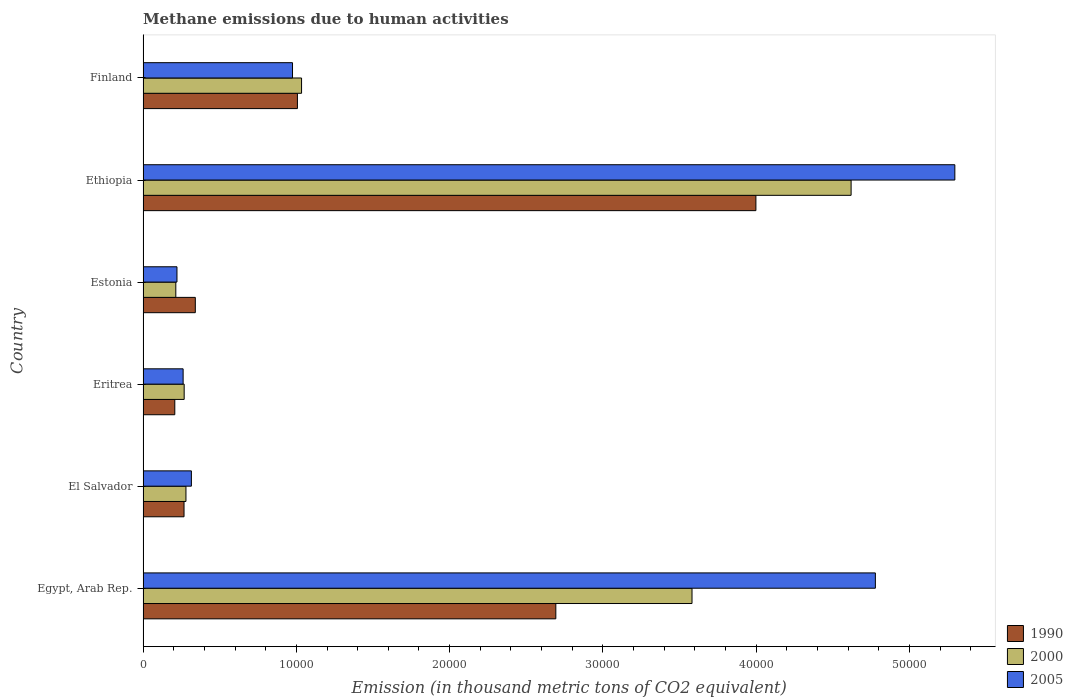What is the label of the 3rd group of bars from the top?
Provide a succinct answer. Estonia. What is the amount of methane emitted in 1990 in El Salvador?
Your response must be concise. 2672.9. Across all countries, what is the maximum amount of methane emitted in 2000?
Your response must be concise. 4.62e+04. Across all countries, what is the minimum amount of methane emitted in 2005?
Offer a very short reply. 2212.3. In which country was the amount of methane emitted in 2005 maximum?
Provide a short and direct response. Ethiopia. In which country was the amount of methane emitted in 1990 minimum?
Offer a terse response. Eritrea. What is the total amount of methane emitted in 2005 in the graph?
Provide a short and direct response. 1.18e+05. What is the difference between the amount of methane emitted in 2005 in El Salvador and that in Eritrea?
Provide a short and direct response. 539.2. What is the difference between the amount of methane emitted in 2005 in Eritrea and the amount of methane emitted in 1990 in Egypt, Arab Rep.?
Provide a short and direct response. -2.43e+04. What is the average amount of methane emitted in 2000 per country?
Keep it short and to the point. 1.67e+04. What is the difference between the amount of methane emitted in 2000 and amount of methane emitted in 1990 in Ethiopia?
Keep it short and to the point. 6210.5. In how many countries, is the amount of methane emitted in 1990 greater than 24000 thousand metric tons?
Offer a terse response. 2. What is the ratio of the amount of methane emitted in 2000 in Egypt, Arab Rep. to that in El Salvador?
Keep it short and to the point. 12.8. Is the amount of methane emitted in 1990 in Eritrea less than that in Ethiopia?
Offer a terse response. Yes. What is the difference between the highest and the second highest amount of methane emitted in 2005?
Give a very brief answer. 5184.5. What is the difference between the highest and the lowest amount of methane emitted in 2000?
Offer a terse response. 4.41e+04. In how many countries, is the amount of methane emitted in 2000 greater than the average amount of methane emitted in 2000 taken over all countries?
Give a very brief answer. 2. Is the sum of the amount of methane emitted in 1990 in El Salvador and Estonia greater than the maximum amount of methane emitted in 2005 across all countries?
Your answer should be very brief. No. What does the 1st bar from the top in El Salvador represents?
Ensure brevity in your answer.  2005. Are all the bars in the graph horizontal?
Give a very brief answer. Yes. Does the graph contain any zero values?
Provide a succinct answer. No. Does the graph contain grids?
Provide a succinct answer. No. Where does the legend appear in the graph?
Keep it short and to the point. Bottom right. What is the title of the graph?
Give a very brief answer. Methane emissions due to human activities. What is the label or title of the X-axis?
Offer a terse response. Emission (in thousand metric tons of CO2 equivalent). What is the Emission (in thousand metric tons of CO2 equivalent) of 1990 in Egypt, Arab Rep.?
Your response must be concise. 2.69e+04. What is the Emission (in thousand metric tons of CO2 equivalent) of 2000 in Egypt, Arab Rep.?
Make the answer very short. 3.58e+04. What is the Emission (in thousand metric tons of CO2 equivalent) of 2005 in Egypt, Arab Rep.?
Make the answer very short. 4.78e+04. What is the Emission (in thousand metric tons of CO2 equivalent) in 1990 in El Salvador?
Ensure brevity in your answer.  2672.9. What is the Emission (in thousand metric tons of CO2 equivalent) of 2000 in El Salvador?
Your response must be concise. 2798.1. What is the Emission (in thousand metric tons of CO2 equivalent) of 2005 in El Salvador?
Offer a very short reply. 3152.8. What is the Emission (in thousand metric tons of CO2 equivalent) of 1990 in Eritrea?
Provide a succinct answer. 2070.6. What is the Emission (in thousand metric tons of CO2 equivalent) in 2000 in Eritrea?
Keep it short and to the point. 2682.3. What is the Emission (in thousand metric tons of CO2 equivalent) in 2005 in Eritrea?
Give a very brief answer. 2613.6. What is the Emission (in thousand metric tons of CO2 equivalent) in 1990 in Estonia?
Your answer should be very brief. 3408.3. What is the Emission (in thousand metric tons of CO2 equivalent) of 2000 in Estonia?
Your answer should be compact. 2136.3. What is the Emission (in thousand metric tons of CO2 equivalent) of 2005 in Estonia?
Keep it short and to the point. 2212.3. What is the Emission (in thousand metric tons of CO2 equivalent) of 1990 in Ethiopia?
Keep it short and to the point. 4.00e+04. What is the Emission (in thousand metric tons of CO2 equivalent) in 2000 in Ethiopia?
Your answer should be compact. 4.62e+04. What is the Emission (in thousand metric tons of CO2 equivalent) in 2005 in Ethiopia?
Your answer should be compact. 5.30e+04. What is the Emission (in thousand metric tons of CO2 equivalent) in 1990 in Finland?
Your answer should be very brief. 1.01e+04. What is the Emission (in thousand metric tons of CO2 equivalent) in 2000 in Finland?
Give a very brief answer. 1.03e+04. What is the Emission (in thousand metric tons of CO2 equivalent) in 2005 in Finland?
Offer a very short reply. 9750. Across all countries, what is the maximum Emission (in thousand metric tons of CO2 equivalent) of 1990?
Offer a very short reply. 4.00e+04. Across all countries, what is the maximum Emission (in thousand metric tons of CO2 equivalent) of 2000?
Keep it short and to the point. 4.62e+04. Across all countries, what is the maximum Emission (in thousand metric tons of CO2 equivalent) of 2005?
Provide a short and direct response. 5.30e+04. Across all countries, what is the minimum Emission (in thousand metric tons of CO2 equivalent) of 1990?
Keep it short and to the point. 2070.6. Across all countries, what is the minimum Emission (in thousand metric tons of CO2 equivalent) of 2000?
Your response must be concise. 2136.3. Across all countries, what is the minimum Emission (in thousand metric tons of CO2 equivalent) in 2005?
Ensure brevity in your answer.  2212.3. What is the total Emission (in thousand metric tons of CO2 equivalent) of 1990 in the graph?
Offer a very short reply. 8.51e+04. What is the total Emission (in thousand metric tons of CO2 equivalent) of 2000 in the graph?
Your answer should be compact. 1.00e+05. What is the total Emission (in thousand metric tons of CO2 equivalent) of 2005 in the graph?
Make the answer very short. 1.18e+05. What is the difference between the Emission (in thousand metric tons of CO2 equivalent) of 1990 in Egypt, Arab Rep. and that in El Salvador?
Your response must be concise. 2.43e+04. What is the difference between the Emission (in thousand metric tons of CO2 equivalent) of 2000 in Egypt, Arab Rep. and that in El Salvador?
Your answer should be very brief. 3.30e+04. What is the difference between the Emission (in thousand metric tons of CO2 equivalent) in 2005 in Egypt, Arab Rep. and that in El Salvador?
Offer a very short reply. 4.46e+04. What is the difference between the Emission (in thousand metric tons of CO2 equivalent) of 1990 in Egypt, Arab Rep. and that in Eritrea?
Keep it short and to the point. 2.49e+04. What is the difference between the Emission (in thousand metric tons of CO2 equivalent) of 2000 in Egypt, Arab Rep. and that in Eritrea?
Keep it short and to the point. 3.31e+04. What is the difference between the Emission (in thousand metric tons of CO2 equivalent) in 2005 in Egypt, Arab Rep. and that in Eritrea?
Offer a very short reply. 4.52e+04. What is the difference between the Emission (in thousand metric tons of CO2 equivalent) of 1990 in Egypt, Arab Rep. and that in Estonia?
Make the answer very short. 2.35e+04. What is the difference between the Emission (in thousand metric tons of CO2 equivalent) in 2000 in Egypt, Arab Rep. and that in Estonia?
Keep it short and to the point. 3.37e+04. What is the difference between the Emission (in thousand metric tons of CO2 equivalent) in 2005 in Egypt, Arab Rep. and that in Estonia?
Your response must be concise. 4.56e+04. What is the difference between the Emission (in thousand metric tons of CO2 equivalent) in 1990 in Egypt, Arab Rep. and that in Ethiopia?
Your response must be concise. -1.31e+04. What is the difference between the Emission (in thousand metric tons of CO2 equivalent) of 2000 in Egypt, Arab Rep. and that in Ethiopia?
Make the answer very short. -1.04e+04. What is the difference between the Emission (in thousand metric tons of CO2 equivalent) in 2005 in Egypt, Arab Rep. and that in Ethiopia?
Make the answer very short. -5184.5. What is the difference between the Emission (in thousand metric tons of CO2 equivalent) of 1990 in Egypt, Arab Rep. and that in Finland?
Keep it short and to the point. 1.69e+04. What is the difference between the Emission (in thousand metric tons of CO2 equivalent) of 2000 in Egypt, Arab Rep. and that in Finland?
Offer a very short reply. 2.55e+04. What is the difference between the Emission (in thousand metric tons of CO2 equivalent) of 2005 in Egypt, Arab Rep. and that in Finland?
Keep it short and to the point. 3.80e+04. What is the difference between the Emission (in thousand metric tons of CO2 equivalent) in 1990 in El Salvador and that in Eritrea?
Offer a terse response. 602.3. What is the difference between the Emission (in thousand metric tons of CO2 equivalent) in 2000 in El Salvador and that in Eritrea?
Your answer should be compact. 115.8. What is the difference between the Emission (in thousand metric tons of CO2 equivalent) in 2005 in El Salvador and that in Eritrea?
Give a very brief answer. 539.2. What is the difference between the Emission (in thousand metric tons of CO2 equivalent) in 1990 in El Salvador and that in Estonia?
Offer a terse response. -735.4. What is the difference between the Emission (in thousand metric tons of CO2 equivalent) in 2000 in El Salvador and that in Estonia?
Offer a terse response. 661.8. What is the difference between the Emission (in thousand metric tons of CO2 equivalent) of 2005 in El Salvador and that in Estonia?
Your answer should be very brief. 940.5. What is the difference between the Emission (in thousand metric tons of CO2 equivalent) in 1990 in El Salvador and that in Ethiopia?
Offer a very short reply. -3.73e+04. What is the difference between the Emission (in thousand metric tons of CO2 equivalent) in 2000 in El Salvador and that in Ethiopia?
Ensure brevity in your answer.  -4.34e+04. What is the difference between the Emission (in thousand metric tons of CO2 equivalent) of 2005 in El Salvador and that in Ethiopia?
Your answer should be compact. -4.98e+04. What is the difference between the Emission (in thousand metric tons of CO2 equivalent) in 1990 in El Salvador and that in Finland?
Your response must be concise. -7397.3. What is the difference between the Emission (in thousand metric tons of CO2 equivalent) of 2000 in El Salvador and that in Finland?
Your answer should be very brief. -7542.7. What is the difference between the Emission (in thousand metric tons of CO2 equivalent) of 2005 in El Salvador and that in Finland?
Keep it short and to the point. -6597.2. What is the difference between the Emission (in thousand metric tons of CO2 equivalent) of 1990 in Eritrea and that in Estonia?
Your answer should be compact. -1337.7. What is the difference between the Emission (in thousand metric tons of CO2 equivalent) of 2000 in Eritrea and that in Estonia?
Keep it short and to the point. 546. What is the difference between the Emission (in thousand metric tons of CO2 equivalent) in 2005 in Eritrea and that in Estonia?
Ensure brevity in your answer.  401.3. What is the difference between the Emission (in thousand metric tons of CO2 equivalent) in 1990 in Eritrea and that in Ethiopia?
Your response must be concise. -3.79e+04. What is the difference between the Emission (in thousand metric tons of CO2 equivalent) of 2000 in Eritrea and that in Ethiopia?
Provide a succinct answer. -4.35e+04. What is the difference between the Emission (in thousand metric tons of CO2 equivalent) of 2005 in Eritrea and that in Ethiopia?
Make the answer very short. -5.03e+04. What is the difference between the Emission (in thousand metric tons of CO2 equivalent) of 1990 in Eritrea and that in Finland?
Ensure brevity in your answer.  -7999.6. What is the difference between the Emission (in thousand metric tons of CO2 equivalent) in 2000 in Eritrea and that in Finland?
Offer a very short reply. -7658.5. What is the difference between the Emission (in thousand metric tons of CO2 equivalent) in 2005 in Eritrea and that in Finland?
Your answer should be very brief. -7136.4. What is the difference between the Emission (in thousand metric tons of CO2 equivalent) in 1990 in Estonia and that in Ethiopia?
Give a very brief answer. -3.66e+04. What is the difference between the Emission (in thousand metric tons of CO2 equivalent) in 2000 in Estonia and that in Ethiopia?
Your answer should be very brief. -4.41e+04. What is the difference between the Emission (in thousand metric tons of CO2 equivalent) of 2005 in Estonia and that in Ethiopia?
Offer a very short reply. -5.07e+04. What is the difference between the Emission (in thousand metric tons of CO2 equivalent) in 1990 in Estonia and that in Finland?
Provide a succinct answer. -6661.9. What is the difference between the Emission (in thousand metric tons of CO2 equivalent) in 2000 in Estonia and that in Finland?
Your answer should be compact. -8204.5. What is the difference between the Emission (in thousand metric tons of CO2 equivalent) of 2005 in Estonia and that in Finland?
Offer a very short reply. -7537.7. What is the difference between the Emission (in thousand metric tons of CO2 equivalent) in 1990 in Ethiopia and that in Finland?
Provide a succinct answer. 2.99e+04. What is the difference between the Emission (in thousand metric tons of CO2 equivalent) of 2000 in Ethiopia and that in Finland?
Ensure brevity in your answer.  3.59e+04. What is the difference between the Emission (in thousand metric tons of CO2 equivalent) in 2005 in Ethiopia and that in Finland?
Provide a short and direct response. 4.32e+04. What is the difference between the Emission (in thousand metric tons of CO2 equivalent) of 1990 in Egypt, Arab Rep. and the Emission (in thousand metric tons of CO2 equivalent) of 2000 in El Salvador?
Offer a very short reply. 2.41e+04. What is the difference between the Emission (in thousand metric tons of CO2 equivalent) of 1990 in Egypt, Arab Rep. and the Emission (in thousand metric tons of CO2 equivalent) of 2005 in El Salvador?
Offer a terse response. 2.38e+04. What is the difference between the Emission (in thousand metric tons of CO2 equivalent) of 2000 in Egypt, Arab Rep. and the Emission (in thousand metric tons of CO2 equivalent) of 2005 in El Salvador?
Your answer should be very brief. 3.27e+04. What is the difference between the Emission (in thousand metric tons of CO2 equivalent) in 1990 in Egypt, Arab Rep. and the Emission (in thousand metric tons of CO2 equivalent) in 2000 in Eritrea?
Give a very brief answer. 2.42e+04. What is the difference between the Emission (in thousand metric tons of CO2 equivalent) of 1990 in Egypt, Arab Rep. and the Emission (in thousand metric tons of CO2 equivalent) of 2005 in Eritrea?
Your response must be concise. 2.43e+04. What is the difference between the Emission (in thousand metric tons of CO2 equivalent) of 2000 in Egypt, Arab Rep. and the Emission (in thousand metric tons of CO2 equivalent) of 2005 in Eritrea?
Offer a terse response. 3.32e+04. What is the difference between the Emission (in thousand metric tons of CO2 equivalent) of 1990 in Egypt, Arab Rep. and the Emission (in thousand metric tons of CO2 equivalent) of 2000 in Estonia?
Offer a very short reply. 2.48e+04. What is the difference between the Emission (in thousand metric tons of CO2 equivalent) in 1990 in Egypt, Arab Rep. and the Emission (in thousand metric tons of CO2 equivalent) in 2005 in Estonia?
Your answer should be compact. 2.47e+04. What is the difference between the Emission (in thousand metric tons of CO2 equivalent) in 2000 in Egypt, Arab Rep. and the Emission (in thousand metric tons of CO2 equivalent) in 2005 in Estonia?
Your answer should be compact. 3.36e+04. What is the difference between the Emission (in thousand metric tons of CO2 equivalent) of 1990 in Egypt, Arab Rep. and the Emission (in thousand metric tons of CO2 equivalent) of 2000 in Ethiopia?
Make the answer very short. -1.93e+04. What is the difference between the Emission (in thousand metric tons of CO2 equivalent) of 1990 in Egypt, Arab Rep. and the Emission (in thousand metric tons of CO2 equivalent) of 2005 in Ethiopia?
Your answer should be compact. -2.60e+04. What is the difference between the Emission (in thousand metric tons of CO2 equivalent) of 2000 in Egypt, Arab Rep. and the Emission (in thousand metric tons of CO2 equivalent) of 2005 in Ethiopia?
Provide a succinct answer. -1.71e+04. What is the difference between the Emission (in thousand metric tons of CO2 equivalent) of 1990 in Egypt, Arab Rep. and the Emission (in thousand metric tons of CO2 equivalent) of 2000 in Finland?
Keep it short and to the point. 1.66e+04. What is the difference between the Emission (in thousand metric tons of CO2 equivalent) of 1990 in Egypt, Arab Rep. and the Emission (in thousand metric tons of CO2 equivalent) of 2005 in Finland?
Provide a short and direct response. 1.72e+04. What is the difference between the Emission (in thousand metric tons of CO2 equivalent) of 2000 in Egypt, Arab Rep. and the Emission (in thousand metric tons of CO2 equivalent) of 2005 in Finland?
Give a very brief answer. 2.61e+04. What is the difference between the Emission (in thousand metric tons of CO2 equivalent) in 1990 in El Salvador and the Emission (in thousand metric tons of CO2 equivalent) in 2005 in Eritrea?
Ensure brevity in your answer.  59.3. What is the difference between the Emission (in thousand metric tons of CO2 equivalent) in 2000 in El Salvador and the Emission (in thousand metric tons of CO2 equivalent) in 2005 in Eritrea?
Ensure brevity in your answer.  184.5. What is the difference between the Emission (in thousand metric tons of CO2 equivalent) of 1990 in El Salvador and the Emission (in thousand metric tons of CO2 equivalent) of 2000 in Estonia?
Give a very brief answer. 536.6. What is the difference between the Emission (in thousand metric tons of CO2 equivalent) in 1990 in El Salvador and the Emission (in thousand metric tons of CO2 equivalent) in 2005 in Estonia?
Ensure brevity in your answer.  460.6. What is the difference between the Emission (in thousand metric tons of CO2 equivalent) in 2000 in El Salvador and the Emission (in thousand metric tons of CO2 equivalent) in 2005 in Estonia?
Make the answer very short. 585.8. What is the difference between the Emission (in thousand metric tons of CO2 equivalent) in 1990 in El Salvador and the Emission (in thousand metric tons of CO2 equivalent) in 2000 in Ethiopia?
Offer a terse response. -4.35e+04. What is the difference between the Emission (in thousand metric tons of CO2 equivalent) in 1990 in El Salvador and the Emission (in thousand metric tons of CO2 equivalent) in 2005 in Ethiopia?
Give a very brief answer. -5.03e+04. What is the difference between the Emission (in thousand metric tons of CO2 equivalent) of 2000 in El Salvador and the Emission (in thousand metric tons of CO2 equivalent) of 2005 in Ethiopia?
Your response must be concise. -5.02e+04. What is the difference between the Emission (in thousand metric tons of CO2 equivalent) of 1990 in El Salvador and the Emission (in thousand metric tons of CO2 equivalent) of 2000 in Finland?
Your response must be concise. -7667.9. What is the difference between the Emission (in thousand metric tons of CO2 equivalent) of 1990 in El Salvador and the Emission (in thousand metric tons of CO2 equivalent) of 2005 in Finland?
Your answer should be very brief. -7077.1. What is the difference between the Emission (in thousand metric tons of CO2 equivalent) in 2000 in El Salvador and the Emission (in thousand metric tons of CO2 equivalent) in 2005 in Finland?
Your answer should be compact. -6951.9. What is the difference between the Emission (in thousand metric tons of CO2 equivalent) in 1990 in Eritrea and the Emission (in thousand metric tons of CO2 equivalent) in 2000 in Estonia?
Offer a terse response. -65.7. What is the difference between the Emission (in thousand metric tons of CO2 equivalent) in 1990 in Eritrea and the Emission (in thousand metric tons of CO2 equivalent) in 2005 in Estonia?
Offer a terse response. -141.7. What is the difference between the Emission (in thousand metric tons of CO2 equivalent) in 2000 in Eritrea and the Emission (in thousand metric tons of CO2 equivalent) in 2005 in Estonia?
Give a very brief answer. 470. What is the difference between the Emission (in thousand metric tons of CO2 equivalent) of 1990 in Eritrea and the Emission (in thousand metric tons of CO2 equivalent) of 2000 in Ethiopia?
Keep it short and to the point. -4.41e+04. What is the difference between the Emission (in thousand metric tons of CO2 equivalent) in 1990 in Eritrea and the Emission (in thousand metric tons of CO2 equivalent) in 2005 in Ethiopia?
Your answer should be compact. -5.09e+04. What is the difference between the Emission (in thousand metric tons of CO2 equivalent) of 2000 in Eritrea and the Emission (in thousand metric tons of CO2 equivalent) of 2005 in Ethiopia?
Provide a succinct answer. -5.03e+04. What is the difference between the Emission (in thousand metric tons of CO2 equivalent) in 1990 in Eritrea and the Emission (in thousand metric tons of CO2 equivalent) in 2000 in Finland?
Your response must be concise. -8270.2. What is the difference between the Emission (in thousand metric tons of CO2 equivalent) in 1990 in Eritrea and the Emission (in thousand metric tons of CO2 equivalent) in 2005 in Finland?
Provide a short and direct response. -7679.4. What is the difference between the Emission (in thousand metric tons of CO2 equivalent) of 2000 in Eritrea and the Emission (in thousand metric tons of CO2 equivalent) of 2005 in Finland?
Keep it short and to the point. -7067.7. What is the difference between the Emission (in thousand metric tons of CO2 equivalent) of 1990 in Estonia and the Emission (in thousand metric tons of CO2 equivalent) of 2000 in Ethiopia?
Provide a short and direct response. -4.28e+04. What is the difference between the Emission (in thousand metric tons of CO2 equivalent) of 1990 in Estonia and the Emission (in thousand metric tons of CO2 equivalent) of 2005 in Ethiopia?
Your response must be concise. -4.96e+04. What is the difference between the Emission (in thousand metric tons of CO2 equivalent) of 2000 in Estonia and the Emission (in thousand metric tons of CO2 equivalent) of 2005 in Ethiopia?
Make the answer very short. -5.08e+04. What is the difference between the Emission (in thousand metric tons of CO2 equivalent) in 1990 in Estonia and the Emission (in thousand metric tons of CO2 equivalent) in 2000 in Finland?
Make the answer very short. -6932.5. What is the difference between the Emission (in thousand metric tons of CO2 equivalent) of 1990 in Estonia and the Emission (in thousand metric tons of CO2 equivalent) of 2005 in Finland?
Provide a succinct answer. -6341.7. What is the difference between the Emission (in thousand metric tons of CO2 equivalent) of 2000 in Estonia and the Emission (in thousand metric tons of CO2 equivalent) of 2005 in Finland?
Provide a short and direct response. -7613.7. What is the difference between the Emission (in thousand metric tons of CO2 equivalent) in 1990 in Ethiopia and the Emission (in thousand metric tons of CO2 equivalent) in 2000 in Finland?
Provide a succinct answer. 2.96e+04. What is the difference between the Emission (in thousand metric tons of CO2 equivalent) of 1990 in Ethiopia and the Emission (in thousand metric tons of CO2 equivalent) of 2005 in Finland?
Offer a terse response. 3.02e+04. What is the difference between the Emission (in thousand metric tons of CO2 equivalent) in 2000 in Ethiopia and the Emission (in thousand metric tons of CO2 equivalent) in 2005 in Finland?
Offer a terse response. 3.64e+04. What is the average Emission (in thousand metric tons of CO2 equivalent) of 1990 per country?
Provide a succinct answer. 1.42e+04. What is the average Emission (in thousand metric tons of CO2 equivalent) of 2000 per country?
Make the answer very short. 1.67e+04. What is the average Emission (in thousand metric tons of CO2 equivalent) in 2005 per country?
Your answer should be very brief. 1.97e+04. What is the difference between the Emission (in thousand metric tons of CO2 equivalent) in 1990 and Emission (in thousand metric tons of CO2 equivalent) in 2000 in Egypt, Arab Rep.?
Make the answer very short. -8884.8. What is the difference between the Emission (in thousand metric tons of CO2 equivalent) in 1990 and Emission (in thousand metric tons of CO2 equivalent) in 2005 in Egypt, Arab Rep.?
Ensure brevity in your answer.  -2.08e+04. What is the difference between the Emission (in thousand metric tons of CO2 equivalent) of 2000 and Emission (in thousand metric tons of CO2 equivalent) of 2005 in Egypt, Arab Rep.?
Your response must be concise. -1.20e+04. What is the difference between the Emission (in thousand metric tons of CO2 equivalent) in 1990 and Emission (in thousand metric tons of CO2 equivalent) in 2000 in El Salvador?
Your response must be concise. -125.2. What is the difference between the Emission (in thousand metric tons of CO2 equivalent) in 1990 and Emission (in thousand metric tons of CO2 equivalent) in 2005 in El Salvador?
Offer a terse response. -479.9. What is the difference between the Emission (in thousand metric tons of CO2 equivalent) of 2000 and Emission (in thousand metric tons of CO2 equivalent) of 2005 in El Salvador?
Your answer should be compact. -354.7. What is the difference between the Emission (in thousand metric tons of CO2 equivalent) in 1990 and Emission (in thousand metric tons of CO2 equivalent) in 2000 in Eritrea?
Give a very brief answer. -611.7. What is the difference between the Emission (in thousand metric tons of CO2 equivalent) in 1990 and Emission (in thousand metric tons of CO2 equivalent) in 2005 in Eritrea?
Provide a succinct answer. -543. What is the difference between the Emission (in thousand metric tons of CO2 equivalent) in 2000 and Emission (in thousand metric tons of CO2 equivalent) in 2005 in Eritrea?
Keep it short and to the point. 68.7. What is the difference between the Emission (in thousand metric tons of CO2 equivalent) in 1990 and Emission (in thousand metric tons of CO2 equivalent) in 2000 in Estonia?
Your answer should be very brief. 1272. What is the difference between the Emission (in thousand metric tons of CO2 equivalent) of 1990 and Emission (in thousand metric tons of CO2 equivalent) of 2005 in Estonia?
Provide a succinct answer. 1196. What is the difference between the Emission (in thousand metric tons of CO2 equivalent) of 2000 and Emission (in thousand metric tons of CO2 equivalent) of 2005 in Estonia?
Your answer should be very brief. -76. What is the difference between the Emission (in thousand metric tons of CO2 equivalent) in 1990 and Emission (in thousand metric tons of CO2 equivalent) in 2000 in Ethiopia?
Your response must be concise. -6210.5. What is the difference between the Emission (in thousand metric tons of CO2 equivalent) in 1990 and Emission (in thousand metric tons of CO2 equivalent) in 2005 in Ethiopia?
Your response must be concise. -1.30e+04. What is the difference between the Emission (in thousand metric tons of CO2 equivalent) of 2000 and Emission (in thousand metric tons of CO2 equivalent) of 2005 in Ethiopia?
Your response must be concise. -6767.8. What is the difference between the Emission (in thousand metric tons of CO2 equivalent) of 1990 and Emission (in thousand metric tons of CO2 equivalent) of 2000 in Finland?
Give a very brief answer. -270.6. What is the difference between the Emission (in thousand metric tons of CO2 equivalent) in 1990 and Emission (in thousand metric tons of CO2 equivalent) in 2005 in Finland?
Your answer should be very brief. 320.2. What is the difference between the Emission (in thousand metric tons of CO2 equivalent) in 2000 and Emission (in thousand metric tons of CO2 equivalent) in 2005 in Finland?
Keep it short and to the point. 590.8. What is the ratio of the Emission (in thousand metric tons of CO2 equivalent) of 1990 in Egypt, Arab Rep. to that in El Salvador?
Make the answer very short. 10.07. What is the ratio of the Emission (in thousand metric tons of CO2 equivalent) in 2000 in Egypt, Arab Rep. to that in El Salvador?
Offer a very short reply. 12.8. What is the ratio of the Emission (in thousand metric tons of CO2 equivalent) in 2005 in Egypt, Arab Rep. to that in El Salvador?
Provide a succinct answer. 15.15. What is the ratio of the Emission (in thousand metric tons of CO2 equivalent) of 1990 in Egypt, Arab Rep. to that in Eritrea?
Give a very brief answer. 13. What is the ratio of the Emission (in thousand metric tons of CO2 equivalent) in 2000 in Egypt, Arab Rep. to that in Eritrea?
Ensure brevity in your answer.  13.35. What is the ratio of the Emission (in thousand metric tons of CO2 equivalent) in 2005 in Egypt, Arab Rep. to that in Eritrea?
Your response must be concise. 18.28. What is the ratio of the Emission (in thousand metric tons of CO2 equivalent) of 1990 in Egypt, Arab Rep. to that in Estonia?
Provide a short and direct response. 7.9. What is the ratio of the Emission (in thousand metric tons of CO2 equivalent) of 2000 in Egypt, Arab Rep. to that in Estonia?
Your response must be concise. 16.76. What is the ratio of the Emission (in thousand metric tons of CO2 equivalent) of 2005 in Egypt, Arab Rep. to that in Estonia?
Offer a very short reply. 21.6. What is the ratio of the Emission (in thousand metric tons of CO2 equivalent) of 1990 in Egypt, Arab Rep. to that in Ethiopia?
Your answer should be very brief. 0.67. What is the ratio of the Emission (in thousand metric tons of CO2 equivalent) of 2000 in Egypt, Arab Rep. to that in Ethiopia?
Your response must be concise. 0.78. What is the ratio of the Emission (in thousand metric tons of CO2 equivalent) of 2005 in Egypt, Arab Rep. to that in Ethiopia?
Your answer should be very brief. 0.9. What is the ratio of the Emission (in thousand metric tons of CO2 equivalent) of 1990 in Egypt, Arab Rep. to that in Finland?
Make the answer very short. 2.67. What is the ratio of the Emission (in thousand metric tons of CO2 equivalent) of 2000 in Egypt, Arab Rep. to that in Finland?
Your answer should be very brief. 3.46. What is the ratio of the Emission (in thousand metric tons of CO2 equivalent) of 2005 in Egypt, Arab Rep. to that in Finland?
Ensure brevity in your answer.  4.9. What is the ratio of the Emission (in thousand metric tons of CO2 equivalent) of 1990 in El Salvador to that in Eritrea?
Provide a short and direct response. 1.29. What is the ratio of the Emission (in thousand metric tons of CO2 equivalent) of 2000 in El Salvador to that in Eritrea?
Give a very brief answer. 1.04. What is the ratio of the Emission (in thousand metric tons of CO2 equivalent) of 2005 in El Salvador to that in Eritrea?
Your response must be concise. 1.21. What is the ratio of the Emission (in thousand metric tons of CO2 equivalent) in 1990 in El Salvador to that in Estonia?
Make the answer very short. 0.78. What is the ratio of the Emission (in thousand metric tons of CO2 equivalent) in 2000 in El Salvador to that in Estonia?
Keep it short and to the point. 1.31. What is the ratio of the Emission (in thousand metric tons of CO2 equivalent) in 2005 in El Salvador to that in Estonia?
Your answer should be very brief. 1.43. What is the ratio of the Emission (in thousand metric tons of CO2 equivalent) of 1990 in El Salvador to that in Ethiopia?
Offer a very short reply. 0.07. What is the ratio of the Emission (in thousand metric tons of CO2 equivalent) of 2000 in El Salvador to that in Ethiopia?
Offer a very short reply. 0.06. What is the ratio of the Emission (in thousand metric tons of CO2 equivalent) of 2005 in El Salvador to that in Ethiopia?
Provide a short and direct response. 0.06. What is the ratio of the Emission (in thousand metric tons of CO2 equivalent) in 1990 in El Salvador to that in Finland?
Provide a succinct answer. 0.27. What is the ratio of the Emission (in thousand metric tons of CO2 equivalent) of 2000 in El Salvador to that in Finland?
Offer a terse response. 0.27. What is the ratio of the Emission (in thousand metric tons of CO2 equivalent) in 2005 in El Salvador to that in Finland?
Make the answer very short. 0.32. What is the ratio of the Emission (in thousand metric tons of CO2 equivalent) of 1990 in Eritrea to that in Estonia?
Offer a terse response. 0.61. What is the ratio of the Emission (in thousand metric tons of CO2 equivalent) in 2000 in Eritrea to that in Estonia?
Keep it short and to the point. 1.26. What is the ratio of the Emission (in thousand metric tons of CO2 equivalent) in 2005 in Eritrea to that in Estonia?
Provide a succinct answer. 1.18. What is the ratio of the Emission (in thousand metric tons of CO2 equivalent) of 1990 in Eritrea to that in Ethiopia?
Your answer should be compact. 0.05. What is the ratio of the Emission (in thousand metric tons of CO2 equivalent) in 2000 in Eritrea to that in Ethiopia?
Your response must be concise. 0.06. What is the ratio of the Emission (in thousand metric tons of CO2 equivalent) of 2005 in Eritrea to that in Ethiopia?
Provide a succinct answer. 0.05. What is the ratio of the Emission (in thousand metric tons of CO2 equivalent) of 1990 in Eritrea to that in Finland?
Give a very brief answer. 0.21. What is the ratio of the Emission (in thousand metric tons of CO2 equivalent) in 2000 in Eritrea to that in Finland?
Provide a succinct answer. 0.26. What is the ratio of the Emission (in thousand metric tons of CO2 equivalent) of 2005 in Eritrea to that in Finland?
Make the answer very short. 0.27. What is the ratio of the Emission (in thousand metric tons of CO2 equivalent) in 1990 in Estonia to that in Ethiopia?
Offer a terse response. 0.09. What is the ratio of the Emission (in thousand metric tons of CO2 equivalent) in 2000 in Estonia to that in Ethiopia?
Keep it short and to the point. 0.05. What is the ratio of the Emission (in thousand metric tons of CO2 equivalent) of 2005 in Estonia to that in Ethiopia?
Give a very brief answer. 0.04. What is the ratio of the Emission (in thousand metric tons of CO2 equivalent) in 1990 in Estonia to that in Finland?
Keep it short and to the point. 0.34. What is the ratio of the Emission (in thousand metric tons of CO2 equivalent) in 2000 in Estonia to that in Finland?
Give a very brief answer. 0.21. What is the ratio of the Emission (in thousand metric tons of CO2 equivalent) in 2005 in Estonia to that in Finland?
Provide a succinct answer. 0.23. What is the ratio of the Emission (in thousand metric tons of CO2 equivalent) in 1990 in Ethiopia to that in Finland?
Make the answer very short. 3.97. What is the ratio of the Emission (in thousand metric tons of CO2 equivalent) of 2000 in Ethiopia to that in Finland?
Provide a short and direct response. 4.47. What is the ratio of the Emission (in thousand metric tons of CO2 equivalent) of 2005 in Ethiopia to that in Finland?
Offer a very short reply. 5.43. What is the difference between the highest and the second highest Emission (in thousand metric tons of CO2 equivalent) in 1990?
Provide a succinct answer. 1.31e+04. What is the difference between the highest and the second highest Emission (in thousand metric tons of CO2 equivalent) of 2000?
Provide a short and direct response. 1.04e+04. What is the difference between the highest and the second highest Emission (in thousand metric tons of CO2 equivalent) of 2005?
Make the answer very short. 5184.5. What is the difference between the highest and the lowest Emission (in thousand metric tons of CO2 equivalent) in 1990?
Keep it short and to the point. 3.79e+04. What is the difference between the highest and the lowest Emission (in thousand metric tons of CO2 equivalent) of 2000?
Your answer should be compact. 4.41e+04. What is the difference between the highest and the lowest Emission (in thousand metric tons of CO2 equivalent) of 2005?
Ensure brevity in your answer.  5.07e+04. 